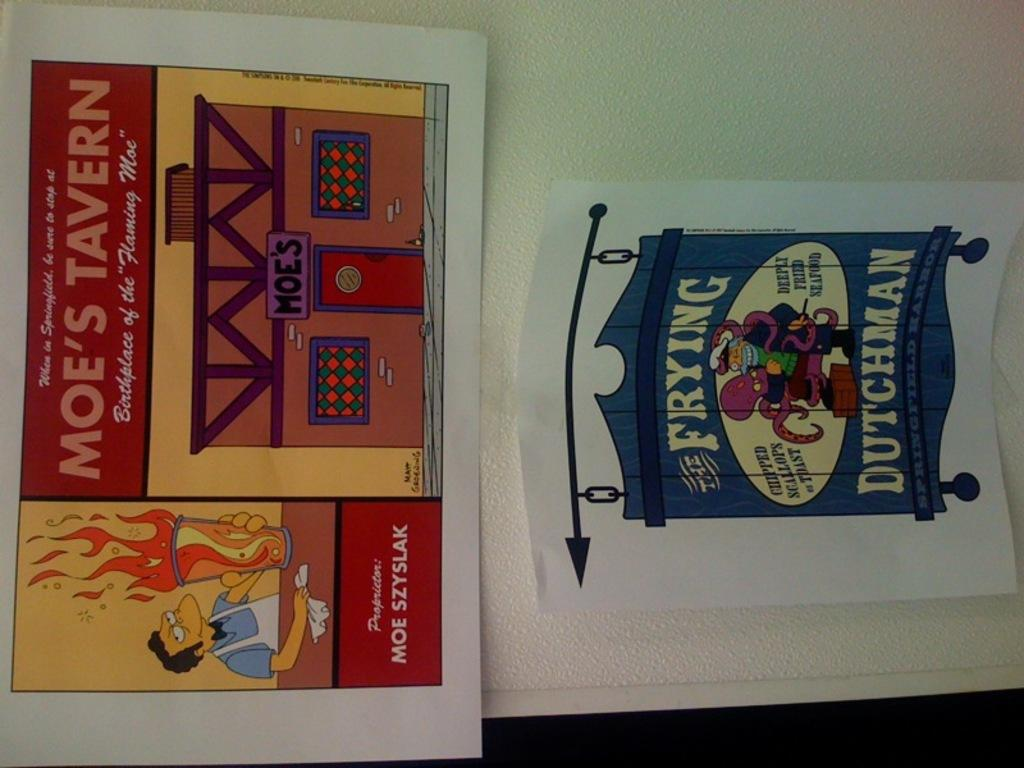<image>
Share a concise interpretation of the image provided. Two signs are taped to a wall and one of them says Moe's Tavern. 